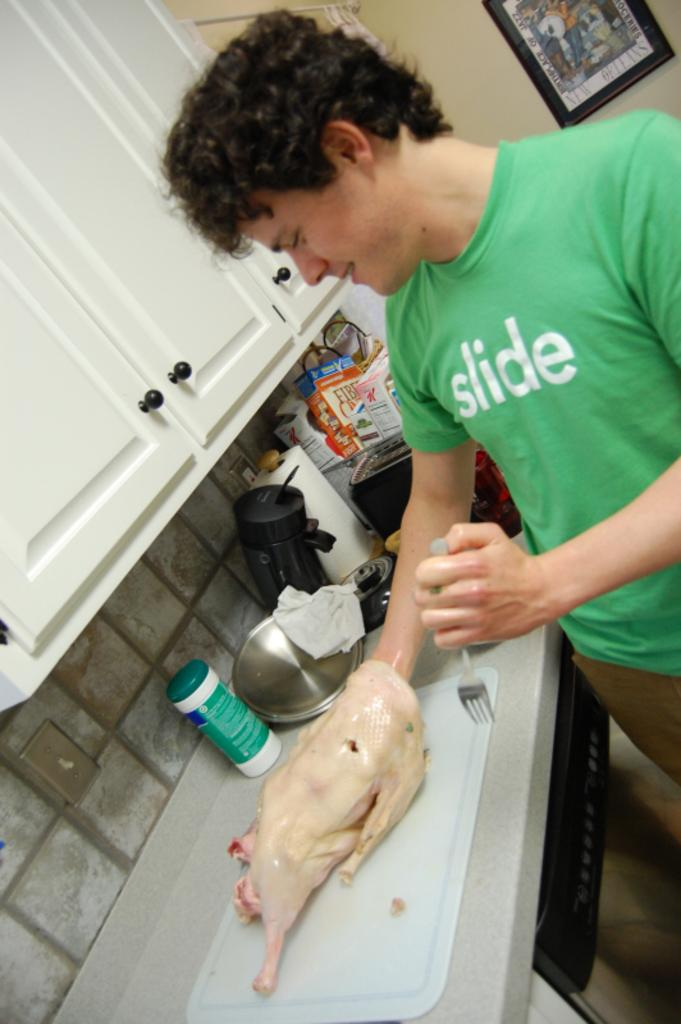<image>
Share a concise interpretation of the image provided. A man in a green slide shirt preparing turkey 